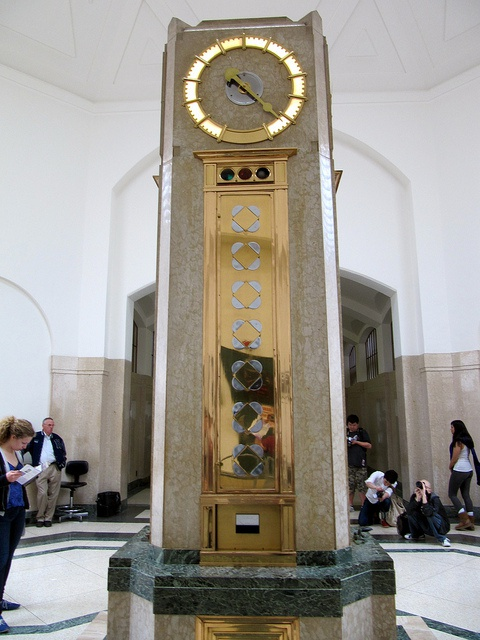Describe the objects in this image and their specific colors. I can see clock in darkgray, gray, tan, and ivory tones, people in darkgray, black, navy, and gray tones, people in darkgray, gray, black, and lavender tones, people in darkgray, black, gray, and navy tones, and people in darkgray, black, and gray tones in this image. 